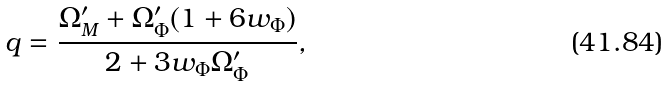Convert formula to latex. <formula><loc_0><loc_0><loc_500><loc_500>q = \frac { \Omega ^ { \prime } _ { M } + \Omega ^ { \prime } _ { \Phi } ( 1 + 6 w _ { \Phi } ) } { 2 + 3 w _ { \Phi } \Omega ^ { \prime } _ { \Phi } } ,</formula> 